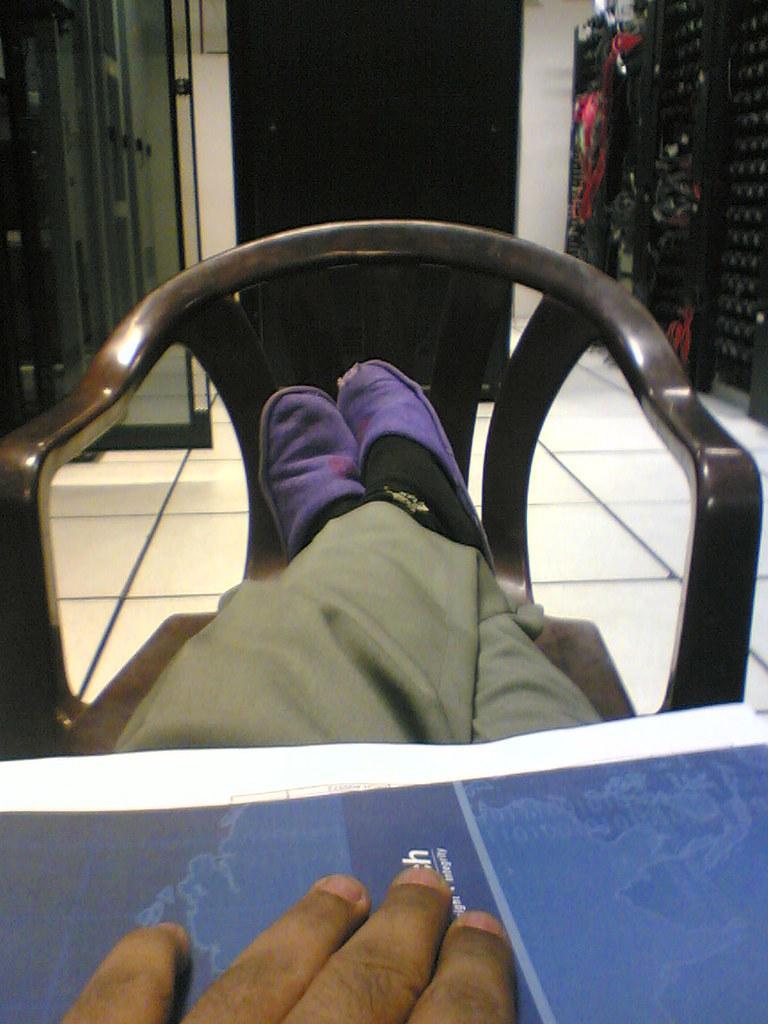Can you describe this image briefly? In the picture we can see a person legs on the chair and on the legs we can see a table space with a person's hand finger and in the background we can see the wall with a door. 